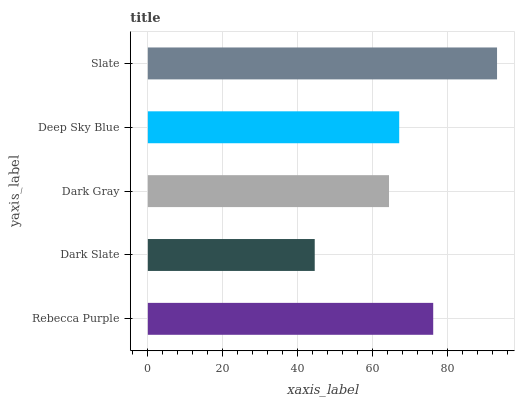Is Dark Slate the minimum?
Answer yes or no. Yes. Is Slate the maximum?
Answer yes or no. Yes. Is Dark Gray the minimum?
Answer yes or no. No. Is Dark Gray the maximum?
Answer yes or no. No. Is Dark Gray greater than Dark Slate?
Answer yes or no. Yes. Is Dark Slate less than Dark Gray?
Answer yes or no. Yes. Is Dark Slate greater than Dark Gray?
Answer yes or no. No. Is Dark Gray less than Dark Slate?
Answer yes or no. No. Is Deep Sky Blue the high median?
Answer yes or no. Yes. Is Deep Sky Blue the low median?
Answer yes or no. Yes. Is Dark Gray the high median?
Answer yes or no. No. Is Dark Gray the low median?
Answer yes or no. No. 